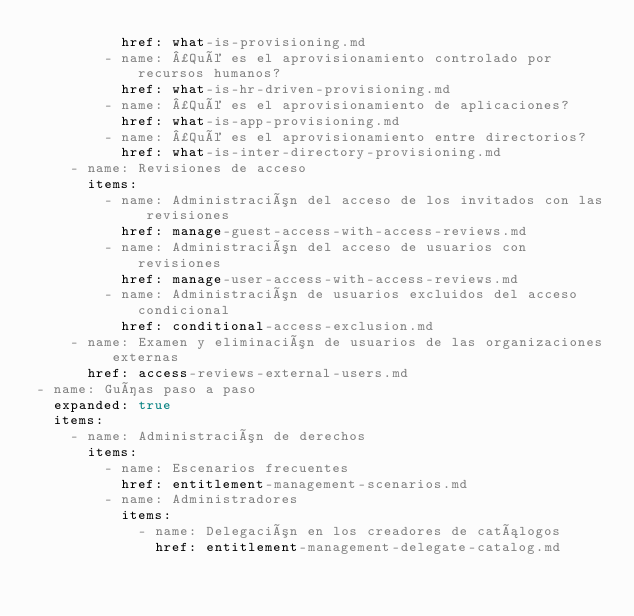Convert code to text. <code><loc_0><loc_0><loc_500><loc_500><_YAML_>          href: what-is-provisioning.md
        - name: ¿Qué es el aprovisionamiento controlado por recursos humanos?
          href: what-is-hr-driven-provisioning.md
        - name: ¿Qué es el aprovisionamiento de aplicaciones?
          href: what-is-app-provisioning.md
        - name: ¿Qué es el aprovisionamiento entre directorios?
          href: what-is-inter-directory-provisioning.md
    - name: Revisiones de acceso
      items:
        - name: Administración del acceso de los invitados con las revisiones
          href: manage-guest-access-with-access-reviews.md
        - name: Administración del acceso de usuarios con revisiones
          href: manage-user-access-with-access-reviews.md
        - name: Administración de usuarios excluidos del acceso condicional
          href: conditional-access-exclusion.md
    - name: Examen y eliminación de usuarios de las organizaciones externas
      href: access-reviews-external-users.md
- name: Guías paso a paso
  expanded: true
  items:
    - name: Administración de derechos
      items:
        - name: Escenarios frecuentes
          href: entitlement-management-scenarios.md
        - name: Administradores
          items:
            - name: Delegación en los creadores de catálogos
              href: entitlement-management-delegate-catalog.md</code> 